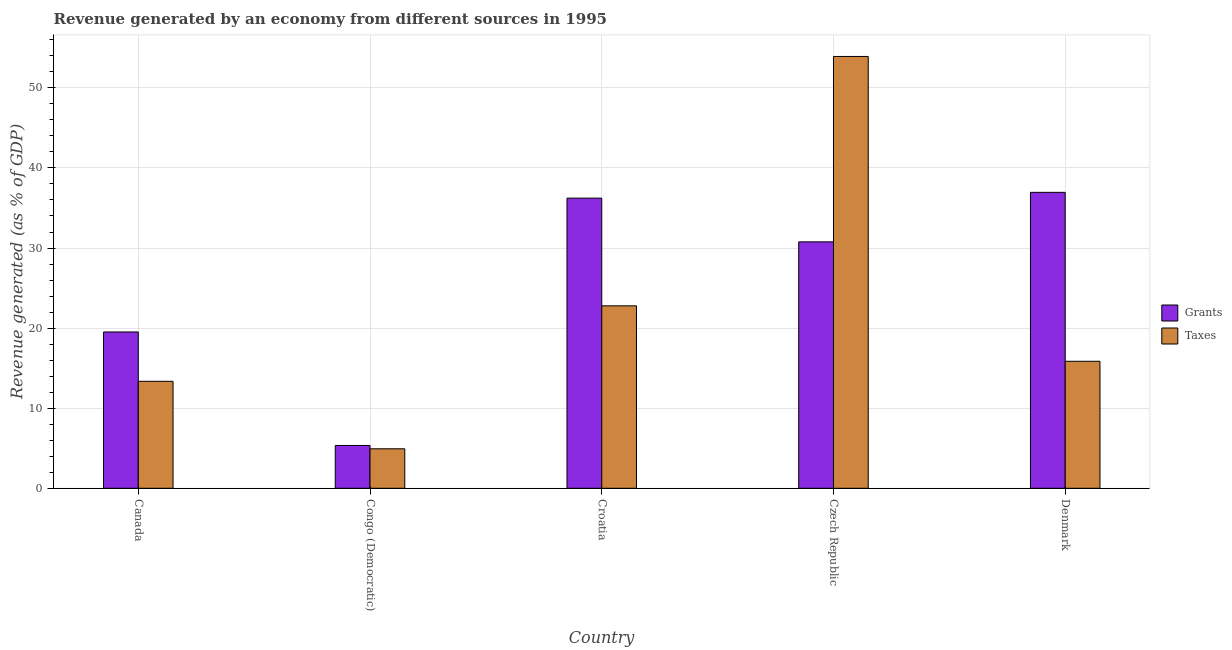How many groups of bars are there?
Your response must be concise. 5. Are the number of bars per tick equal to the number of legend labels?
Keep it short and to the point. Yes. Are the number of bars on each tick of the X-axis equal?
Your answer should be very brief. Yes. How many bars are there on the 5th tick from the left?
Your answer should be compact. 2. How many bars are there on the 1st tick from the right?
Your answer should be very brief. 2. What is the label of the 2nd group of bars from the left?
Ensure brevity in your answer.  Congo (Democratic). What is the revenue generated by grants in Congo (Democratic)?
Your response must be concise. 5.35. Across all countries, what is the maximum revenue generated by taxes?
Your response must be concise. 53.92. Across all countries, what is the minimum revenue generated by grants?
Ensure brevity in your answer.  5.35. In which country was the revenue generated by grants minimum?
Make the answer very short. Congo (Democratic). What is the total revenue generated by taxes in the graph?
Keep it short and to the point. 110.85. What is the difference between the revenue generated by grants in Croatia and that in Denmark?
Offer a terse response. -0.72. What is the difference between the revenue generated by grants in Croatia and the revenue generated by taxes in Czech Republic?
Your answer should be very brief. -17.69. What is the average revenue generated by taxes per country?
Offer a very short reply. 22.17. What is the difference between the revenue generated by grants and revenue generated by taxes in Czech Republic?
Keep it short and to the point. -23.15. What is the ratio of the revenue generated by taxes in Croatia to that in Czech Republic?
Give a very brief answer. 0.42. Is the difference between the revenue generated by grants in Canada and Croatia greater than the difference between the revenue generated by taxes in Canada and Croatia?
Offer a terse response. No. What is the difference between the highest and the second highest revenue generated by taxes?
Make the answer very short. 31.14. What is the difference between the highest and the lowest revenue generated by taxes?
Ensure brevity in your answer.  48.99. In how many countries, is the revenue generated by taxes greater than the average revenue generated by taxes taken over all countries?
Your answer should be compact. 2. What does the 2nd bar from the left in Czech Republic represents?
Offer a very short reply. Taxes. What does the 1st bar from the right in Czech Republic represents?
Offer a very short reply. Taxes. How many countries are there in the graph?
Your answer should be very brief. 5. What is the difference between two consecutive major ticks on the Y-axis?
Your response must be concise. 10. Are the values on the major ticks of Y-axis written in scientific E-notation?
Offer a terse response. No. Does the graph contain any zero values?
Ensure brevity in your answer.  No. Does the graph contain grids?
Your response must be concise. Yes. How many legend labels are there?
Keep it short and to the point. 2. How are the legend labels stacked?
Ensure brevity in your answer.  Vertical. What is the title of the graph?
Provide a succinct answer. Revenue generated by an economy from different sources in 1995. Does "Chemicals" appear as one of the legend labels in the graph?
Keep it short and to the point. No. What is the label or title of the X-axis?
Your response must be concise. Country. What is the label or title of the Y-axis?
Your answer should be compact. Revenue generated (as % of GDP). What is the Revenue generated (as % of GDP) in Grants in Canada?
Make the answer very short. 19.52. What is the Revenue generated (as % of GDP) of Taxes in Canada?
Ensure brevity in your answer.  13.36. What is the Revenue generated (as % of GDP) in Grants in Congo (Democratic)?
Your answer should be compact. 5.35. What is the Revenue generated (as % of GDP) of Taxes in Congo (Democratic)?
Your response must be concise. 4.93. What is the Revenue generated (as % of GDP) of Grants in Croatia?
Ensure brevity in your answer.  36.23. What is the Revenue generated (as % of GDP) of Taxes in Croatia?
Your response must be concise. 22.78. What is the Revenue generated (as % of GDP) of Grants in Czech Republic?
Provide a succinct answer. 30.77. What is the Revenue generated (as % of GDP) of Taxes in Czech Republic?
Offer a terse response. 53.92. What is the Revenue generated (as % of GDP) in Grants in Denmark?
Your answer should be very brief. 36.95. What is the Revenue generated (as % of GDP) in Taxes in Denmark?
Your answer should be very brief. 15.86. Across all countries, what is the maximum Revenue generated (as % of GDP) in Grants?
Keep it short and to the point. 36.95. Across all countries, what is the maximum Revenue generated (as % of GDP) of Taxes?
Give a very brief answer. 53.92. Across all countries, what is the minimum Revenue generated (as % of GDP) in Grants?
Keep it short and to the point. 5.35. Across all countries, what is the minimum Revenue generated (as % of GDP) of Taxes?
Provide a succinct answer. 4.93. What is the total Revenue generated (as % of GDP) of Grants in the graph?
Provide a short and direct response. 128.82. What is the total Revenue generated (as % of GDP) in Taxes in the graph?
Provide a succinct answer. 110.85. What is the difference between the Revenue generated (as % of GDP) of Grants in Canada and that in Congo (Democratic)?
Keep it short and to the point. 14.17. What is the difference between the Revenue generated (as % of GDP) of Taxes in Canada and that in Congo (Democratic)?
Your answer should be very brief. 8.43. What is the difference between the Revenue generated (as % of GDP) in Grants in Canada and that in Croatia?
Your response must be concise. -16.71. What is the difference between the Revenue generated (as % of GDP) in Taxes in Canada and that in Croatia?
Your answer should be compact. -9.42. What is the difference between the Revenue generated (as % of GDP) in Grants in Canada and that in Czech Republic?
Provide a short and direct response. -11.25. What is the difference between the Revenue generated (as % of GDP) in Taxes in Canada and that in Czech Republic?
Ensure brevity in your answer.  -40.56. What is the difference between the Revenue generated (as % of GDP) in Grants in Canada and that in Denmark?
Offer a terse response. -17.43. What is the difference between the Revenue generated (as % of GDP) of Taxes in Canada and that in Denmark?
Keep it short and to the point. -2.5. What is the difference between the Revenue generated (as % of GDP) of Grants in Congo (Democratic) and that in Croatia?
Your answer should be very brief. -30.88. What is the difference between the Revenue generated (as % of GDP) in Taxes in Congo (Democratic) and that in Croatia?
Provide a succinct answer. -17.85. What is the difference between the Revenue generated (as % of GDP) of Grants in Congo (Democratic) and that in Czech Republic?
Your answer should be compact. -25.42. What is the difference between the Revenue generated (as % of GDP) in Taxes in Congo (Democratic) and that in Czech Republic?
Your answer should be very brief. -48.99. What is the difference between the Revenue generated (as % of GDP) in Grants in Congo (Democratic) and that in Denmark?
Provide a short and direct response. -31.6. What is the difference between the Revenue generated (as % of GDP) in Taxes in Congo (Democratic) and that in Denmark?
Your answer should be very brief. -10.93. What is the difference between the Revenue generated (as % of GDP) in Grants in Croatia and that in Czech Republic?
Provide a short and direct response. 5.46. What is the difference between the Revenue generated (as % of GDP) of Taxes in Croatia and that in Czech Republic?
Offer a terse response. -31.14. What is the difference between the Revenue generated (as % of GDP) in Grants in Croatia and that in Denmark?
Keep it short and to the point. -0.72. What is the difference between the Revenue generated (as % of GDP) in Taxes in Croatia and that in Denmark?
Give a very brief answer. 6.92. What is the difference between the Revenue generated (as % of GDP) of Grants in Czech Republic and that in Denmark?
Offer a terse response. -6.18. What is the difference between the Revenue generated (as % of GDP) in Taxes in Czech Republic and that in Denmark?
Offer a terse response. 38.06. What is the difference between the Revenue generated (as % of GDP) of Grants in Canada and the Revenue generated (as % of GDP) of Taxes in Congo (Democratic)?
Your answer should be compact. 14.59. What is the difference between the Revenue generated (as % of GDP) of Grants in Canada and the Revenue generated (as % of GDP) of Taxes in Croatia?
Provide a succinct answer. -3.26. What is the difference between the Revenue generated (as % of GDP) in Grants in Canada and the Revenue generated (as % of GDP) in Taxes in Czech Republic?
Provide a short and direct response. -34.4. What is the difference between the Revenue generated (as % of GDP) of Grants in Canada and the Revenue generated (as % of GDP) of Taxes in Denmark?
Your answer should be very brief. 3.66. What is the difference between the Revenue generated (as % of GDP) in Grants in Congo (Democratic) and the Revenue generated (as % of GDP) in Taxes in Croatia?
Your response must be concise. -17.43. What is the difference between the Revenue generated (as % of GDP) in Grants in Congo (Democratic) and the Revenue generated (as % of GDP) in Taxes in Czech Republic?
Your answer should be compact. -48.57. What is the difference between the Revenue generated (as % of GDP) of Grants in Congo (Democratic) and the Revenue generated (as % of GDP) of Taxes in Denmark?
Your response must be concise. -10.51. What is the difference between the Revenue generated (as % of GDP) of Grants in Croatia and the Revenue generated (as % of GDP) of Taxes in Czech Republic?
Ensure brevity in your answer.  -17.69. What is the difference between the Revenue generated (as % of GDP) of Grants in Croatia and the Revenue generated (as % of GDP) of Taxes in Denmark?
Keep it short and to the point. 20.37. What is the difference between the Revenue generated (as % of GDP) of Grants in Czech Republic and the Revenue generated (as % of GDP) of Taxes in Denmark?
Keep it short and to the point. 14.91. What is the average Revenue generated (as % of GDP) in Grants per country?
Your answer should be compact. 25.76. What is the average Revenue generated (as % of GDP) of Taxes per country?
Ensure brevity in your answer.  22.17. What is the difference between the Revenue generated (as % of GDP) in Grants and Revenue generated (as % of GDP) in Taxes in Canada?
Offer a very short reply. 6.16. What is the difference between the Revenue generated (as % of GDP) of Grants and Revenue generated (as % of GDP) of Taxes in Congo (Democratic)?
Make the answer very short. 0.42. What is the difference between the Revenue generated (as % of GDP) of Grants and Revenue generated (as % of GDP) of Taxes in Croatia?
Ensure brevity in your answer.  13.45. What is the difference between the Revenue generated (as % of GDP) of Grants and Revenue generated (as % of GDP) of Taxes in Czech Republic?
Ensure brevity in your answer.  -23.15. What is the difference between the Revenue generated (as % of GDP) in Grants and Revenue generated (as % of GDP) in Taxes in Denmark?
Provide a succinct answer. 21.09. What is the ratio of the Revenue generated (as % of GDP) in Grants in Canada to that in Congo (Democratic)?
Offer a terse response. 3.65. What is the ratio of the Revenue generated (as % of GDP) in Taxes in Canada to that in Congo (Democratic)?
Ensure brevity in your answer.  2.71. What is the ratio of the Revenue generated (as % of GDP) in Grants in Canada to that in Croatia?
Provide a short and direct response. 0.54. What is the ratio of the Revenue generated (as % of GDP) in Taxes in Canada to that in Croatia?
Ensure brevity in your answer.  0.59. What is the ratio of the Revenue generated (as % of GDP) in Grants in Canada to that in Czech Republic?
Offer a very short reply. 0.63. What is the ratio of the Revenue generated (as % of GDP) of Taxes in Canada to that in Czech Republic?
Give a very brief answer. 0.25. What is the ratio of the Revenue generated (as % of GDP) of Grants in Canada to that in Denmark?
Your answer should be very brief. 0.53. What is the ratio of the Revenue generated (as % of GDP) in Taxes in Canada to that in Denmark?
Your answer should be compact. 0.84. What is the ratio of the Revenue generated (as % of GDP) of Grants in Congo (Democratic) to that in Croatia?
Your response must be concise. 0.15. What is the ratio of the Revenue generated (as % of GDP) in Taxes in Congo (Democratic) to that in Croatia?
Give a very brief answer. 0.22. What is the ratio of the Revenue generated (as % of GDP) in Grants in Congo (Democratic) to that in Czech Republic?
Provide a short and direct response. 0.17. What is the ratio of the Revenue generated (as % of GDP) in Taxes in Congo (Democratic) to that in Czech Republic?
Make the answer very short. 0.09. What is the ratio of the Revenue generated (as % of GDP) in Grants in Congo (Democratic) to that in Denmark?
Make the answer very short. 0.14. What is the ratio of the Revenue generated (as % of GDP) of Taxes in Congo (Democratic) to that in Denmark?
Give a very brief answer. 0.31. What is the ratio of the Revenue generated (as % of GDP) of Grants in Croatia to that in Czech Republic?
Keep it short and to the point. 1.18. What is the ratio of the Revenue generated (as % of GDP) of Taxes in Croatia to that in Czech Republic?
Offer a very short reply. 0.42. What is the ratio of the Revenue generated (as % of GDP) in Grants in Croatia to that in Denmark?
Give a very brief answer. 0.98. What is the ratio of the Revenue generated (as % of GDP) in Taxes in Croatia to that in Denmark?
Keep it short and to the point. 1.44. What is the ratio of the Revenue generated (as % of GDP) of Grants in Czech Republic to that in Denmark?
Make the answer very short. 0.83. What is the ratio of the Revenue generated (as % of GDP) of Taxes in Czech Republic to that in Denmark?
Provide a short and direct response. 3.4. What is the difference between the highest and the second highest Revenue generated (as % of GDP) in Grants?
Offer a very short reply. 0.72. What is the difference between the highest and the second highest Revenue generated (as % of GDP) of Taxes?
Offer a terse response. 31.14. What is the difference between the highest and the lowest Revenue generated (as % of GDP) of Grants?
Offer a very short reply. 31.6. What is the difference between the highest and the lowest Revenue generated (as % of GDP) in Taxes?
Your answer should be very brief. 48.99. 